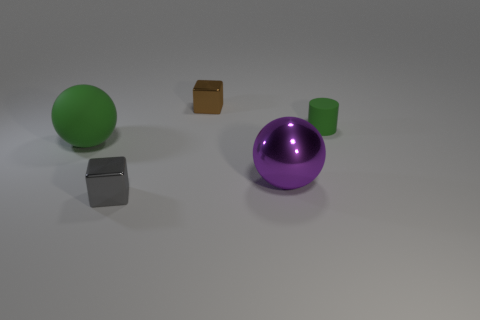Subtract 1 cylinders. How many cylinders are left? 0 Add 4 cyan objects. How many objects exist? 9 Subtract all green balls. How many balls are left? 1 Add 3 tiny gray metallic things. How many tiny gray metallic things exist? 4 Subtract 0 brown cylinders. How many objects are left? 5 Subtract all cylinders. How many objects are left? 4 Subtract all green cubes. Subtract all blue balls. How many cubes are left? 2 Subtract all brown spheres. How many cyan blocks are left? 0 Subtract all big green blocks. Subtract all small green matte cylinders. How many objects are left? 4 Add 5 green rubber balls. How many green rubber balls are left? 6 